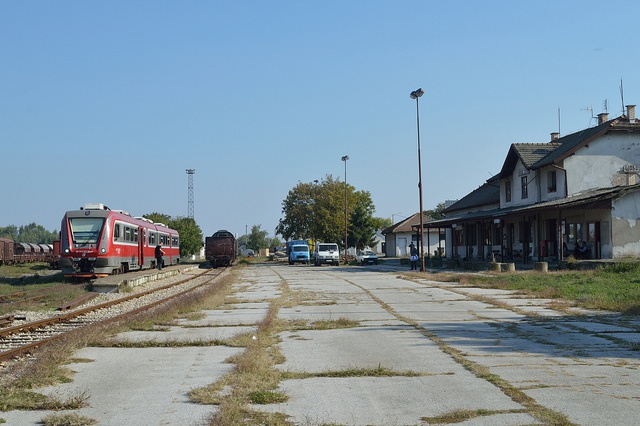Describe the objects in this image and their specific colors. I can see train in darkgray, black, gray, and brown tones, train in darkgray, black, and gray tones, truck in darkgray, black, blue, and navy tones, truck in darkgray, black, gray, and lightgray tones, and car in darkgray, black, and gray tones in this image. 